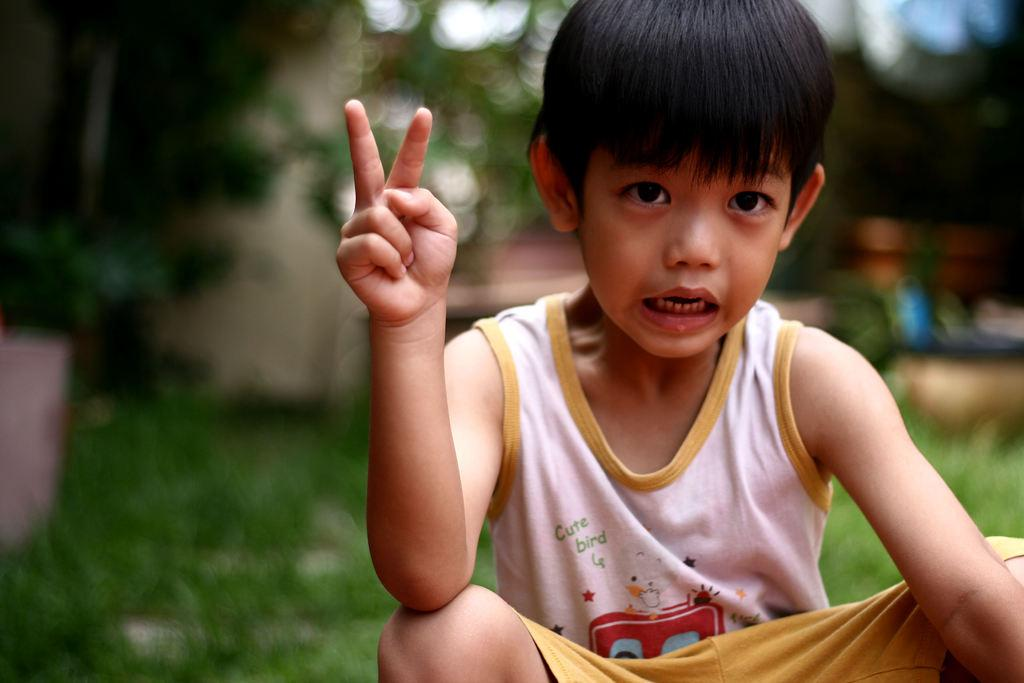What is the main subject of the picture? The main subject of the picture is a boy. What can be seen in the background of the picture? There is grass visible in the background of the picture. What type of lace can be seen on the boy's clothing in the picture? There is no lace visible on the boy's clothing in the picture. Can you describe the boat in the background of the picture? There is no boat present in the picture; it only features a boy and grass in the background. 